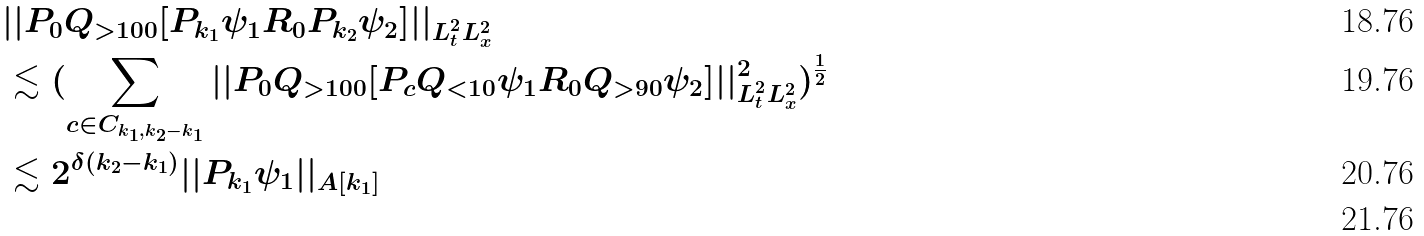Convert formula to latex. <formula><loc_0><loc_0><loc_500><loc_500>& | | P _ { 0 } Q _ { > 1 0 0 } [ P _ { k _ { 1 } } \psi _ { 1 } R _ { 0 } P _ { k _ { 2 } } \psi _ { 2 } ] | | _ { L _ { t } ^ { 2 } L _ { x } ^ { 2 } } \\ & \lesssim ( \sum _ { c \in C _ { k _ { 1 } , k _ { 2 } - k _ { 1 } } } | | P _ { 0 } Q _ { > 1 0 0 } [ P _ { c } Q _ { < 1 0 } \psi _ { 1 } R _ { 0 } Q _ { > 9 0 } \psi _ { 2 } ] | | _ { L _ { t } ^ { 2 } L _ { x } ^ { 2 } } ^ { 2 } ) ^ { \frac { 1 } { 2 } } \\ & \lesssim 2 ^ { \delta ( k _ { 2 } - k _ { 1 } ) } | | P _ { k _ { 1 } } \psi _ { 1 } | | _ { A [ k _ { 1 } ] } \\</formula> 